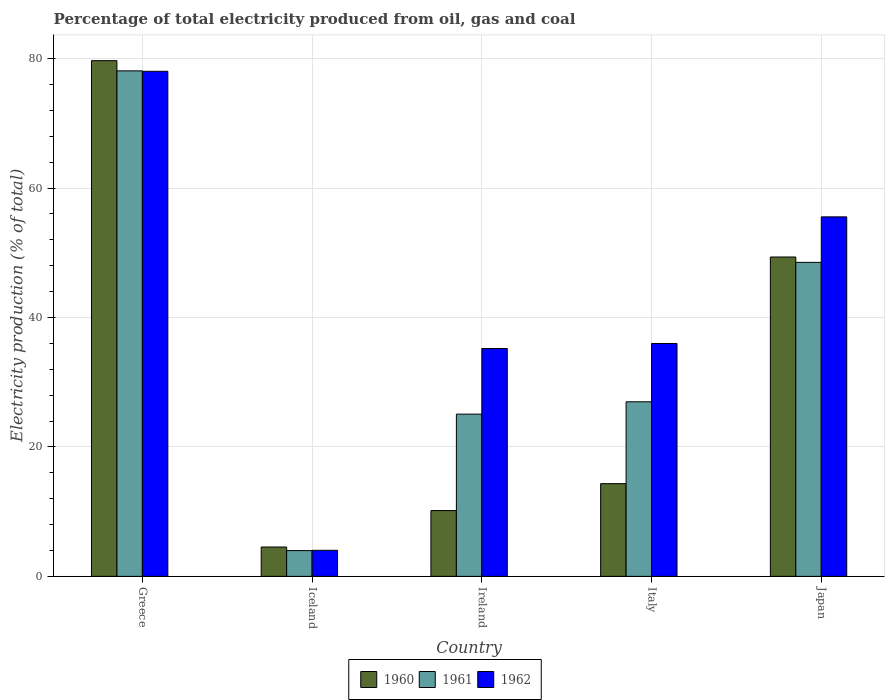How many different coloured bars are there?
Your response must be concise. 3. Are the number of bars per tick equal to the number of legend labels?
Your answer should be very brief. Yes. Are the number of bars on each tick of the X-axis equal?
Offer a very short reply. Yes. What is the label of the 4th group of bars from the left?
Provide a succinct answer. Italy. In how many cases, is the number of bars for a given country not equal to the number of legend labels?
Give a very brief answer. 0. What is the electricity production in in 1962 in Japan?
Your answer should be compact. 55.56. Across all countries, what is the maximum electricity production in in 1962?
Your answer should be compact. 78.05. Across all countries, what is the minimum electricity production in in 1961?
Provide a short and direct response. 3.98. In which country was the electricity production in in 1960 maximum?
Provide a short and direct response. Greece. What is the total electricity production in in 1961 in the graph?
Your answer should be very brief. 182.67. What is the difference between the electricity production in in 1961 in Greece and that in Japan?
Your answer should be compact. 29.59. What is the difference between the electricity production in in 1962 in Italy and the electricity production in in 1961 in Iceland?
Provide a succinct answer. 32.01. What is the average electricity production in in 1962 per country?
Give a very brief answer. 41.77. What is the difference between the electricity production in of/in 1962 and electricity production in of/in 1961 in Ireland?
Provide a succinct answer. 10.14. In how many countries, is the electricity production in in 1961 greater than 20 %?
Make the answer very short. 4. What is the ratio of the electricity production in in 1962 in Italy to that in Japan?
Keep it short and to the point. 0.65. Is the electricity production in in 1961 in Iceland less than that in Japan?
Provide a short and direct response. Yes. What is the difference between the highest and the second highest electricity production in in 1962?
Provide a short and direct response. -42.06. What is the difference between the highest and the lowest electricity production in in 1960?
Your response must be concise. 75.16. In how many countries, is the electricity production in in 1961 greater than the average electricity production in in 1961 taken over all countries?
Ensure brevity in your answer.  2. Is the sum of the electricity production in in 1962 in Italy and Japan greater than the maximum electricity production in in 1960 across all countries?
Provide a short and direct response. Yes. What does the 3rd bar from the right in Greece represents?
Make the answer very short. 1960. Is it the case that in every country, the sum of the electricity production in in 1962 and electricity production in in 1961 is greater than the electricity production in in 1960?
Offer a very short reply. Yes. Are all the bars in the graph horizontal?
Provide a short and direct response. No. How many countries are there in the graph?
Keep it short and to the point. 5. What is the difference between two consecutive major ticks on the Y-axis?
Provide a succinct answer. 20. Does the graph contain any zero values?
Provide a succinct answer. No. Does the graph contain grids?
Keep it short and to the point. Yes. Where does the legend appear in the graph?
Your response must be concise. Bottom center. How are the legend labels stacked?
Give a very brief answer. Horizontal. What is the title of the graph?
Make the answer very short. Percentage of total electricity produced from oil, gas and coal. What is the label or title of the Y-axis?
Provide a succinct answer. Electricity production (% of total). What is the Electricity production (% of total) in 1960 in Greece?
Your answer should be compact. 79.69. What is the Electricity production (% of total) of 1961 in Greece?
Provide a short and direct response. 78.12. What is the Electricity production (% of total) in 1962 in Greece?
Provide a short and direct response. 78.05. What is the Electricity production (% of total) of 1960 in Iceland?
Your answer should be compact. 4.54. What is the Electricity production (% of total) of 1961 in Iceland?
Ensure brevity in your answer.  3.98. What is the Electricity production (% of total) in 1962 in Iceland?
Keep it short and to the point. 4.03. What is the Electricity production (% of total) in 1960 in Ireland?
Provide a succinct answer. 10.17. What is the Electricity production (% of total) of 1961 in Ireland?
Make the answer very short. 25.07. What is the Electricity production (% of total) of 1962 in Ireland?
Offer a terse response. 35.21. What is the Electricity production (% of total) in 1960 in Italy?
Ensure brevity in your answer.  14.33. What is the Electricity production (% of total) of 1961 in Italy?
Offer a terse response. 26.98. What is the Electricity production (% of total) in 1962 in Italy?
Give a very brief answer. 35.99. What is the Electricity production (% of total) of 1960 in Japan?
Offer a very short reply. 49.35. What is the Electricity production (% of total) of 1961 in Japan?
Your answer should be compact. 48.52. What is the Electricity production (% of total) of 1962 in Japan?
Your answer should be compact. 55.56. Across all countries, what is the maximum Electricity production (% of total) in 1960?
Your answer should be compact. 79.69. Across all countries, what is the maximum Electricity production (% of total) of 1961?
Give a very brief answer. 78.12. Across all countries, what is the maximum Electricity production (% of total) in 1962?
Offer a terse response. 78.05. Across all countries, what is the minimum Electricity production (% of total) in 1960?
Ensure brevity in your answer.  4.54. Across all countries, what is the minimum Electricity production (% of total) in 1961?
Offer a terse response. 3.98. Across all countries, what is the minimum Electricity production (% of total) of 1962?
Provide a short and direct response. 4.03. What is the total Electricity production (% of total) in 1960 in the graph?
Make the answer very short. 158.08. What is the total Electricity production (% of total) in 1961 in the graph?
Offer a very short reply. 182.67. What is the total Electricity production (% of total) in 1962 in the graph?
Provide a short and direct response. 208.83. What is the difference between the Electricity production (% of total) of 1960 in Greece and that in Iceland?
Offer a very short reply. 75.16. What is the difference between the Electricity production (% of total) of 1961 in Greece and that in Iceland?
Offer a very short reply. 74.14. What is the difference between the Electricity production (% of total) in 1962 in Greece and that in Iceland?
Offer a very short reply. 74.02. What is the difference between the Electricity production (% of total) of 1960 in Greece and that in Ireland?
Make the answer very short. 69.53. What is the difference between the Electricity production (% of total) of 1961 in Greece and that in Ireland?
Give a very brief answer. 53.05. What is the difference between the Electricity production (% of total) in 1962 in Greece and that in Ireland?
Ensure brevity in your answer.  42.84. What is the difference between the Electricity production (% of total) in 1960 in Greece and that in Italy?
Make the answer very short. 65.37. What is the difference between the Electricity production (% of total) in 1961 in Greece and that in Italy?
Make the answer very short. 51.14. What is the difference between the Electricity production (% of total) in 1962 in Greece and that in Italy?
Provide a short and direct response. 42.06. What is the difference between the Electricity production (% of total) in 1960 in Greece and that in Japan?
Ensure brevity in your answer.  30.34. What is the difference between the Electricity production (% of total) in 1961 in Greece and that in Japan?
Keep it short and to the point. 29.59. What is the difference between the Electricity production (% of total) in 1962 in Greece and that in Japan?
Your answer should be very brief. 22.49. What is the difference between the Electricity production (% of total) of 1960 in Iceland and that in Ireland?
Give a very brief answer. -5.63. What is the difference between the Electricity production (% of total) in 1961 in Iceland and that in Ireland?
Your answer should be very brief. -21.09. What is the difference between the Electricity production (% of total) of 1962 in Iceland and that in Ireland?
Your answer should be compact. -31.19. What is the difference between the Electricity production (% of total) in 1960 in Iceland and that in Italy?
Give a very brief answer. -9.79. What is the difference between the Electricity production (% of total) in 1961 in Iceland and that in Italy?
Your response must be concise. -23. What is the difference between the Electricity production (% of total) in 1962 in Iceland and that in Italy?
Make the answer very short. -31.96. What is the difference between the Electricity production (% of total) in 1960 in Iceland and that in Japan?
Your answer should be very brief. -44.81. What is the difference between the Electricity production (% of total) in 1961 in Iceland and that in Japan?
Your answer should be very brief. -44.54. What is the difference between the Electricity production (% of total) of 1962 in Iceland and that in Japan?
Your response must be concise. -51.53. What is the difference between the Electricity production (% of total) of 1960 in Ireland and that in Italy?
Offer a very short reply. -4.16. What is the difference between the Electricity production (% of total) in 1961 in Ireland and that in Italy?
Offer a very short reply. -1.91. What is the difference between the Electricity production (% of total) of 1962 in Ireland and that in Italy?
Your response must be concise. -0.78. What is the difference between the Electricity production (% of total) of 1960 in Ireland and that in Japan?
Your answer should be compact. -39.18. What is the difference between the Electricity production (% of total) in 1961 in Ireland and that in Japan?
Ensure brevity in your answer.  -23.45. What is the difference between the Electricity production (% of total) of 1962 in Ireland and that in Japan?
Make the answer very short. -20.34. What is the difference between the Electricity production (% of total) of 1960 in Italy and that in Japan?
Make the answer very short. -35.02. What is the difference between the Electricity production (% of total) of 1961 in Italy and that in Japan?
Give a very brief answer. -21.55. What is the difference between the Electricity production (% of total) in 1962 in Italy and that in Japan?
Offer a terse response. -19.57. What is the difference between the Electricity production (% of total) of 1960 in Greece and the Electricity production (% of total) of 1961 in Iceland?
Offer a terse response. 75.71. What is the difference between the Electricity production (% of total) in 1960 in Greece and the Electricity production (% of total) in 1962 in Iceland?
Keep it short and to the point. 75.67. What is the difference between the Electricity production (% of total) of 1961 in Greece and the Electricity production (% of total) of 1962 in Iceland?
Offer a terse response. 74.09. What is the difference between the Electricity production (% of total) in 1960 in Greece and the Electricity production (% of total) in 1961 in Ireland?
Offer a terse response. 54.62. What is the difference between the Electricity production (% of total) of 1960 in Greece and the Electricity production (% of total) of 1962 in Ireland?
Ensure brevity in your answer.  44.48. What is the difference between the Electricity production (% of total) of 1961 in Greece and the Electricity production (% of total) of 1962 in Ireland?
Your answer should be compact. 42.91. What is the difference between the Electricity production (% of total) of 1960 in Greece and the Electricity production (% of total) of 1961 in Italy?
Provide a succinct answer. 52.72. What is the difference between the Electricity production (% of total) in 1960 in Greece and the Electricity production (% of total) in 1962 in Italy?
Your answer should be very brief. 43.71. What is the difference between the Electricity production (% of total) of 1961 in Greece and the Electricity production (% of total) of 1962 in Italy?
Ensure brevity in your answer.  42.13. What is the difference between the Electricity production (% of total) of 1960 in Greece and the Electricity production (% of total) of 1961 in Japan?
Your answer should be very brief. 31.17. What is the difference between the Electricity production (% of total) in 1960 in Greece and the Electricity production (% of total) in 1962 in Japan?
Ensure brevity in your answer.  24.14. What is the difference between the Electricity production (% of total) in 1961 in Greece and the Electricity production (% of total) in 1962 in Japan?
Give a very brief answer. 22.56. What is the difference between the Electricity production (% of total) in 1960 in Iceland and the Electricity production (% of total) in 1961 in Ireland?
Keep it short and to the point. -20.53. What is the difference between the Electricity production (% of total) in 1960 in Iceland and the Electricity production (% of total) in 1962 in Ireland?
Give a very brief answer. -30.67. What is the difference between the Electricity production (% of total) of 1961 in Iceland and the Electricity production (% of total) of 1962 in Ireland?
Your response must be concise. -31.23. What is the difference between the Electricity production (% of total) of 1960 in Iceland and the Electricity production (% of total) of 1961 in Italy?
Provide a succinct answer. -22.44. What is the difference between the Electricity production (% of total) of 1960 in Iceland and the Electricity production (% of total) of 1962 in Italy?
Provide a short and direct response. -31.45. What is the difference between the Electricity production (% of total) of 1961 in Iceland and the Electricity production (% of total) of 1962 in Italy?
Provide a succinct answer. -32.01. What is the difference between the Electricity production (% of total) in 1960 in Iceland and the Electricity production (% of total) in 1961 in Japan?
Keep it short and to the point. -43.99. What is the difference between the Electricity production (% of total) of 1960 in Iceland and the Electricity production (% of total) of 1962 in Japan?
Keep it short and to the point. -51.02. What is the difference between the Electricity production (% of total) of 1961 in Iceland and the Electricity production (% of total) of 1962 in Japan?
Ensure brevity in your answer.  -51.58. What is the difference between the Electricity production (% of total) of 1960 in Ireland and the Electricity production (% of total) of 1961 in Italy?
Your answer should be very brief. -16.81. What is the difference between the Electricity production (% of total) of 1960 in Ireland and the Electricity production (% of total) of 1962 in Italy?
Make the answer very short. -25.82. What is the difference between the Electricity production (% of total) in 1961 in Ireland and the Electricity production (% of total) in 1962 in Italy?
Make the answer very short. -10.92. What is the difference between the Electricity production (% of total) of 1960 in Ireland and the Electricity production (% of total) of 1961 in Japan?
Your response must be concise. -38.36. What is the difference between the Electricity production (% of total) in 1960 in Ireland and the Electricity production (% of total) in 1962 in Japan?
Offer a terse response. -45.39. What is the difference between the Electricity production (% of total) in 1961 in Ireland and the Electricity production (% of total) in 1962 in Japan?
Offer a very short reply. -30.48. What is the difference between the Electricity production (% of total) in 1960 in Italy and the Electricity production (% of total) in 1961 in Japan?
Provide a succinct answer. -34.2. What is the difference between the Electricity production (% of total) in 1960 in Italy and the Electricity production (% of total) in 1962 in Japan?
Your response must be concise. -41.23. What is the difference between the Electricity production (% of total) of 1961 in Italy and the Electricity production (% of total) of 1962 in Japan?
Give a very brief answer. -28.58. What is the average Electricity production (% of total) in 1960 per country?
Provide a succinct answer. 31.62. What is the average Electricity production (% of total) in 1961 per country?
Your answer should be compact. 36.53. What is the average Electricity production (% of total) of 1962 per country?
Give a very brief answer. 41.77. What is the difference between the Electricity production (% of total) in 1960 and Electricity production (% of total) in 1961 in Greece?
Offer a terse response. 1.58. What is the difference between the Electricity production (% of total) of 1960 and Electricity production (% of total) of 1962 in Greece?
Your response must be concise. 1.64. What is the difference between the Electricity production (% of total) of 1961 and Electricity production (% of total) of 1962 in Greece?
Provide a succinct answer. 0.07. What is the difference between the Electricity production (% of total) in 1960 and Electricity production (% of total) in 1961 in Iceland?
Ensure brevity in your answer.  0.56. What is the difference between the Electricity production (% of total) of 1960 and Electricity production (% of total) of 1962 in Iceland?
Offer a very short reply. 0.51. What is the difference between the Electricity production (% of total) of 1961 and Electricity production (% of total) of 1962 in Iceland?
Offer a terse response. -0.05. What is the difference between the Electricity production (% of total) of 1960 and Electricity production (% of total) of 1961 in Ireland?
Offer a very short reply. -14.9. What is the difference between the Electricity production (% of total) in 1960 and Electricity production (% of total) in 1962 in Ireland?
Give a very brief answer. -25.04. What is the difference between the Electricity production (% of total) of 1961 and Electricity production (% of total) of 1962 in Ireland?
Ensure brevity in your answer.  -10.14. What is the difference between the Electricity production (% of total) in 1960 and Electricity production (% of total) in 1961 in Italy?
Keep it short and to the point. -12.65. What is the difference between the Electricity production (% of total) in 1960 and Electricity production (% of total) in 1962 in Italy?
Give a very brief answer. -21.66. What is the difference between the Electricity production (% of total) in 1961 and Electricity production (% of total) in 1962 in Italy?
Give a very brief answer. -9.01. What is the difference between the Electricity production (% of total) of 1960 and Electricity production (% of total) of 1961 in Japan?
Keep it short and to the point. 0.83. What is the difference between the Electricity production (% of total) in 1960 and Electricity production (% of total) in 1962 in Japan?
Ensure brevity in your answer.  -6.2. What is the difference between the Electricity production (% of total) in 1961 and Electricity production (% of total) in 1962 in Japan?
Provide a short and direct response. -7.03. What is the ratio of the Electricity production (% of total) in 1960 in Greece to that in Iceland?
Your answer should be very brief. 17.56. What is the ratio of the Electricity production (% of total) of 1961 in Greece to that in Iceland?
Offer a terse response. 19.63. What is the ratio of the Electricity production (% of total) in 1962 in Greece to that in Iceland?
Your answer should be very brief. 19.39. What is the ratio of the Electricity production (% of total) in 1960 in Greece to that in Ireland?
Offer a very short reply. 7.84. What is the ratio of the Electricity production (% of total) in 1961 in Greece to that in Ireland?
Offer a very short reply. 3.12. What is the ratio of the Electricity production (% of total) of 1962 in Greece to that in Ireland?
Your answer should be compact. 2.22. What is the ratio of the Electricity production (% of total) in 1960 in Greece to that in Italy?
Your answer should be compact. 5.56. What is the ratio of the Electricity production (% of total) of 1961 in Greece to that in Italy?
Your response must be concise. 2.9. What is the ratio of the Electricity production (% of total) of 1962 in Greece to that in Italy?
Ensure brevity in your answer.  2.17. What is the ratio of the Electricity production (% of total) in 1960 in Greece to that in Japan?
Your response must be concise. 1.61. What is the ratio of the Electricity production (% of total) in 1961 in Greece to that in Japan?
Keep it short and to the point. 1.61. What is the ratio of the Electricity production (% of total) of 1962 in Greece to that in Japan?
Your answer should be very brief. 1.4. What is the ratio of the Electricity production (% of total) of 1960 in Iceland to that in Ireland?
Ensure brevity in your answer.  0.45. What is the ratio of the Electricity production (% of total) of 1961 in Iceland to that in Ireland?
Your answer should be very brief. 0.16. What is the ratio of the Electricity production (% of total) of 1962 in Iceland to that in Ireland?
Give a very brief answer. 0.11. What is the ratio of the Electricity production (% of total) of 1960 in Iceland to that in Italy?
Give a very brief answer. 0.32. What is the ratio of the Electricity production (% of total) in 1961 in Iceland to that in Italy?
Give a very brief answer. 0.15. What is the ratio of the Electricity production (% of total) in 1962 in Iceland to that in Italy?
Offer a very short reply. 0.11. What is the ratio of the Electricity production (% of total) in 1960 in Iceland to that in Japan?
Ensure brevity in your answer.  0.09. What is the ratio of the Electricity production (% of total) in 1961 in Iceland to that in Japan?
Make the answer very short. 0.08. What is the ratio of the Electricity production (% of total) of 1962 in Iceland to that in Japan?
Offer a terse response. 0.07. What is the ratio of the Electricity production (% of total) in 1960 in Ireland to that in Italy?
Provide a succinct answer. 0.71. What is the ratio of the Electricity production (% of total) in 1961 in Ireland to that in Italy?
Provide a short and direct response. 0.93. What is the ratio of the Electricity production (% of total) of 1962 in Ireland to that in Italy?
Your answer should be compact. 0.98. What is the ratio of the Electricity production (% of total) in 1960 in Ireland to that in Japan?
Make the answer very short. 0.21. What is the ratio of the Electricity production (% of total) in 1961 in Ireland to that in Japan?
Provide a succinct answer. 0.52. What is the ratio of the Electricity production (% of total) of 1962 in Ireland to that in Japan?
Provide a short and direct response. 0.63. What is the ratio of the Electricity production (% of total) of 1960 in Italy to that in Japan?
Give a very brief answer. 0.29. What is the ratio of the Electricity production (% of total) of 1961 in Italy to that in Japan?
Your answer should be compact. 0.56. What is the ratio of the Electricity production (% of total) in 1962 in Italy to that in Japan?
Your answer should be compact. 0.65. What is the difference between the highest and the second highest Electricity production (% of total) of 1960?
Give a very brief answer. 30.34. What is the difference between the highest and the second highest Electricity production (% of total) in 1961?
Provide a short and direct response. 29.59. What is the difference between the highest and the second highest Electricity production (% of total) in 1962?
Provide a short and direct response. 22.49. What is the difference between the highest and the lowest Electricity production (% of total) of 1960?
Make the answer very short. 75.16. What is the difference between the highest and the lowest Electricity production (% of total) in 1961?
Your answer should be compact. 74.14. What is the difference between the highest and the lowest Electricity production (% of total) of 1962?
Make the answer very short. 74.02. 